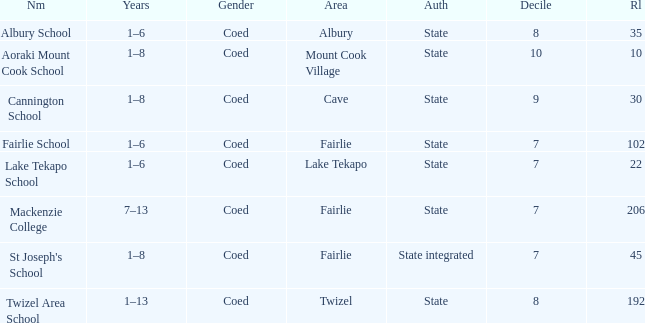What area is named Mackenzie college? Fairlie. 